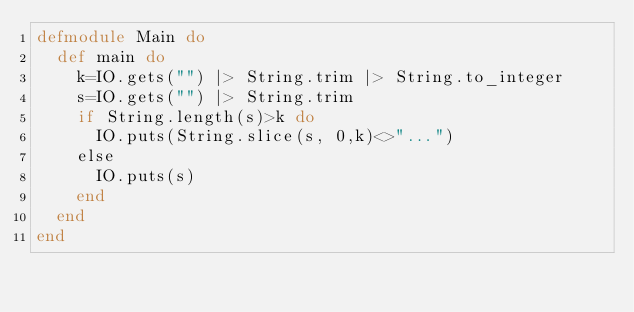Convert code to text. <code><loc_0><loc_0><loc_500><loc_500><_Elixir_>defmodule Main do
  def main do
    k=IO.gets("") |> String.trim |> String.to_integer
    s=IO.gets("") |> String.trim
    if String.length(s)>k do
      IO.puts(String.slice(s, 0,k)<>"...")
    else
      IO.puts(s)
    end
  end
end
</code> 